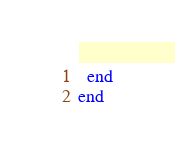Convert code to text. <code><loc_0><loc_0><loc_500><loc_500><_Ruby_>  end
end
</code> 